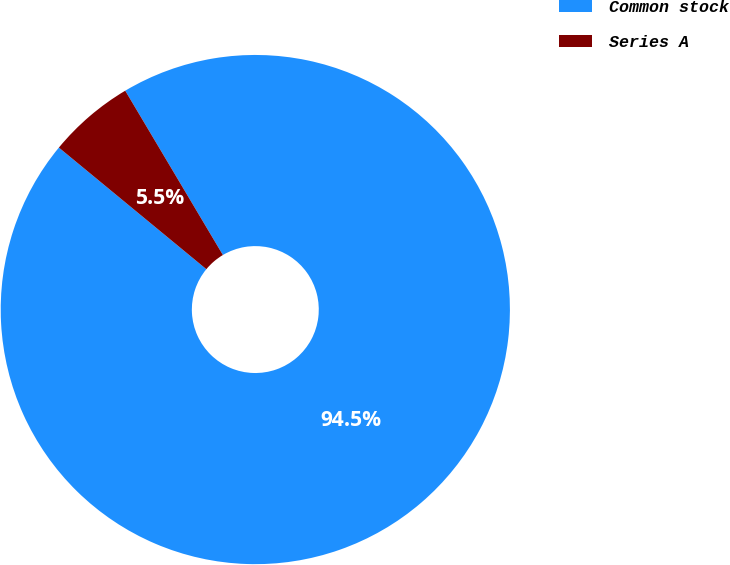Convert chart to OTSL. <chart><loc_0><loc_0><loc_500><loc_500><pie_chart><fcel>Common stock<fcel>Series A<nl><fcel>94.51%<fcel>5.49%<nl></chart> 